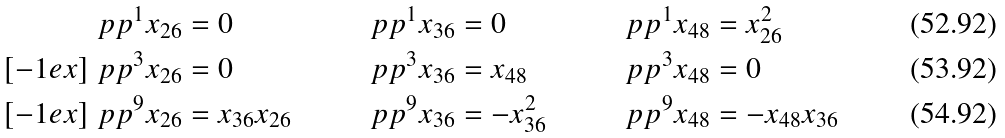Convert formula to latex. <formula><loc_0><loc_0><loc_500><loc_500>\ p p ^ { 1 } x _ { 2 6 } & = 0 & \ p p ^ { 1 } x _ { 3 6 } & = 0 & \ p p ^ { 1 } x _ { 4 8 } & = x _ { 2 6 } ^ { 2 } \\ [ - 1 e x ] \ p p ^ { 3 } x _ { 2 6 } & = 0 & \ p p ^ { 3 } x _ { 3 6 } & = x _ { 4 8 } & \ p p ^ { 3 } x _ { 4 8 } & = 0 \\ [ - 1 e x ] \ p p ^ { 9 } x _ { 2 6 } & = x _ { 3 6 } x _ { 2 6 } & \ p p ^ { 9 } x _ { 3 6 } & = - x _ { 3 6 } ^ { 2 } & \ p p ^ { 9 } x _ { 4 8 } & = - x _ { 4 8 } x _ { 3 6 }</formula> 